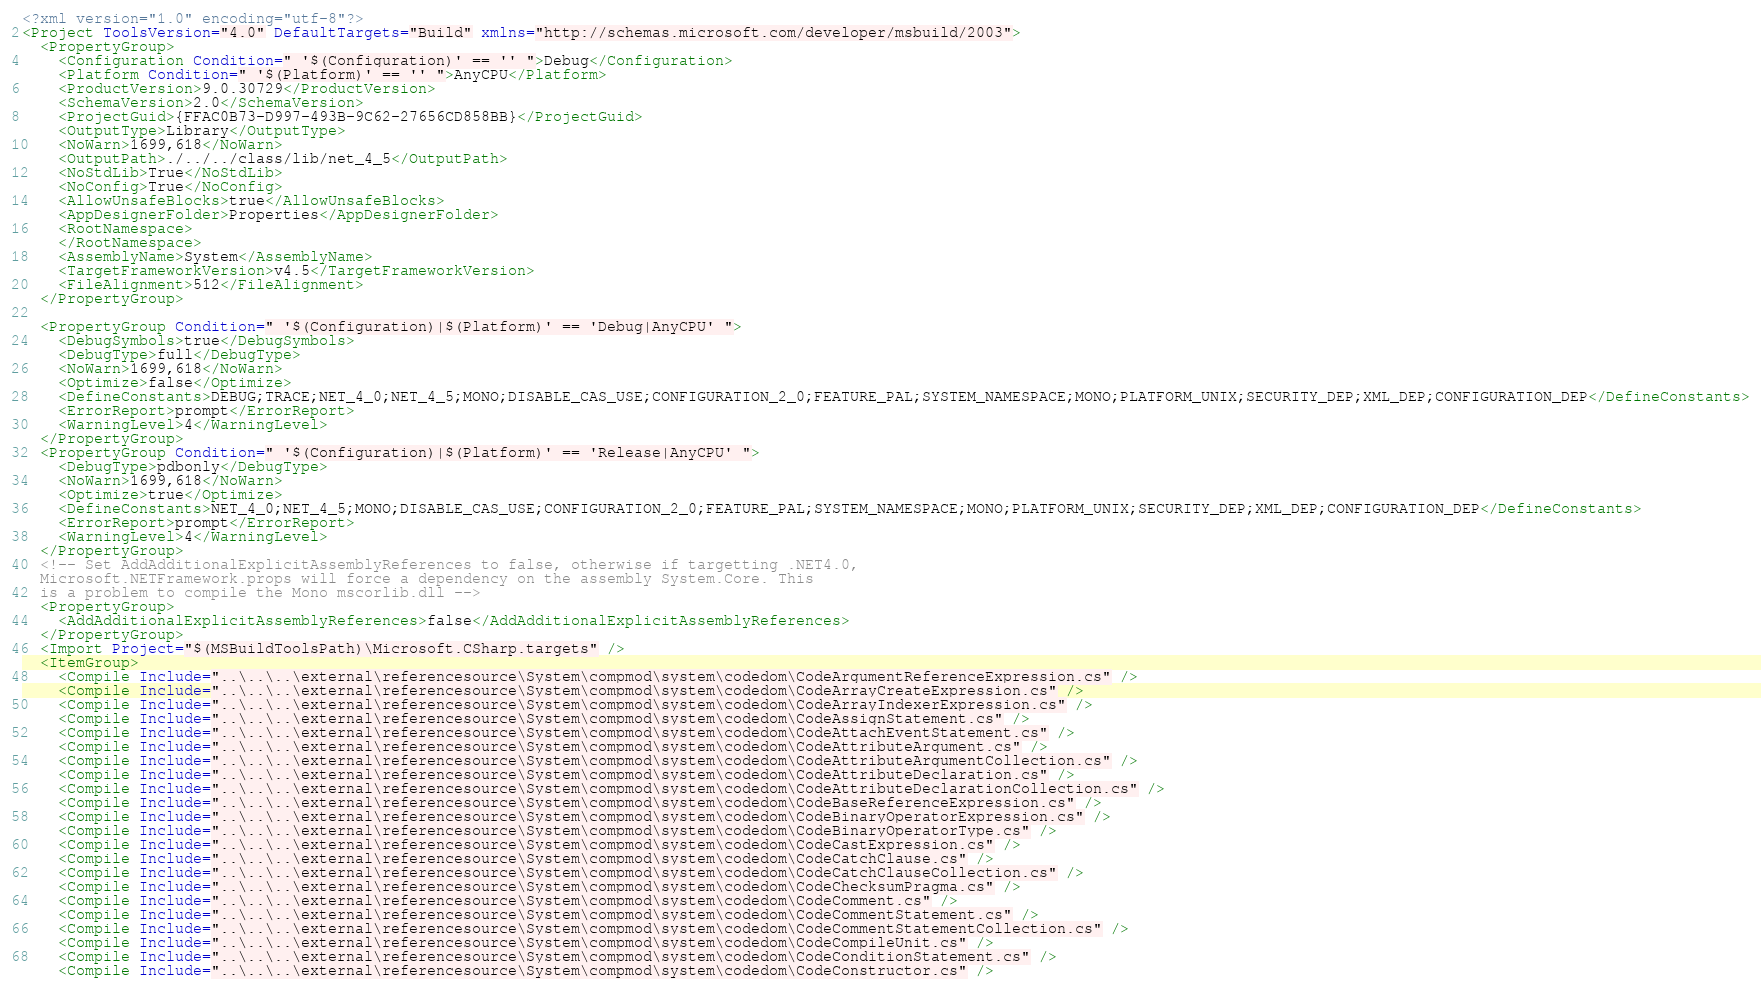<code> <loc_0><loc_0><loc_500><loc_500><_XML_><?xml version="1.0" encoding="utf-8"?>
<Project ToolsVersion="4.0" DefaultTargets="Build" xmlns="http://schemas.microsoft.com/developer/msbuild/2003">
  <PropertyGroup>
    <Configuration Condition=" '$(Configuration)' == '' ">Debug</Configuration>
    <Platform Condition=" '$(Platform)' == '' ">AnyCPU</Platform>
    <ProductVersion>9.0.30729</ProductVersion>
    <SchemaVersion>2.0</SchemaVersion>
    <ProjectGuid>{FFAC0B73-D997-493B-9C62-27656CD858BB}</ProjectGuid>
    <OutputType>Library</OutputType>
    <NoWarn>1699,618</NoWarn>
    <OutputPath>./../../class/lib/net_4_5</OutputPath>
    <NoStdLib>True</NoStdLib>
    <NoConfig>True</NoConfig>
    <AllowUnsafeBlocks>true</AllowUnsafeBlocks>
    <AppDesignerFolder>Properties</AppDesignerFolder>
    <RootNamespace>
    </RootNamespace>
    <AssemblyName>System</AssemblyName>
    <TargetFrameworkVersion>v4.5</TargetFrameworkVersion>
    <FileAlignment>512</FileAlignment>
  </PropertyGroup>
  
  <PropertyGroup Condition=" '$(Configuration)|$(Platform)' == 'Debug|AnyCPU' ">
    <DebugSymbols>true</DebugSymbols>
    <DebugType>full</DebugType>
    <NoWarn>1699,618</NoWarn>
    <Optimize>false</Optimize>
    <DefineConstants>DEBUG;TRACE;NET_4_0;NET_4_5;MONO;DISABLE_CAS_USE;CONFIGURATION_2_0;FEATURE_PAL;SYSTEM_NAMESPACE;MONO;PLATFORM_UNIX;SECURITY_DEP;XML_DEP;CONFIGURATION_DEP</DefineConstants>
    <ErrorReport>prompt</ErrorReport>
    <WarningLevel>4</WarningLevel>
  </PropertyGroup>
  <PropertyGroup Condition=" '$(Configuration)|$(Platform)' == 'Release|AnyCPU' ">
    <DebugType>pdbonly</DebugType>
    <NoWarn>1699,618</NoWarn>
    <Optimize>true</Optimize>
    <DefineConstants>NET_4_0;NET_4_5;MONO;DISABLE_CAS_USE;CONFIGURATION_2_0;FEATURE_PAL;SYSTEM_NAMESPACE;MONO;PLATFORM_UNIX;SECURITY_DEP;XML_DEP;CONFIGURATION_DEP</DefineConstants>
    <ErrorReport>prompt</ErrorReport>
    <WarningLevel>4</WarningLevel>
  </PropertyGroup>
  <!-- Set AddAdditionalExplicitAssemblyReferences to false, otherwise if targetting .NET4.0, 
  Microsoft.NETFramework.props will force a dependency on the assembly System.Core. This
  is a problem to compile the Mono mscorlib.dll -->
  <PropertyGroup>
    <AddAdditionalExplicitAssemblyReferences>false</AddAdditionalExplicitAssemblyReferences>
  </PropertyGroup>
  <Import Project="$(MSBuildToolsPath)\Microsoft.CSharp.targets" />
  <ItemGroup>
    <Compile Include="..\..\..\external\referencesource\System\compmod\system\codedom\CodeArgumentReferenceExpression.cs" />
    <Compile Include="..\..\..\external\referencesource\System\compmod\system\codedom\CodeArrayCreateExpression.cs" />
    <Compile Include="..\..\..\external\referencesource\System\compmod\system\codedom\CodeArrayIndexerExpression.cs" />
    <Compile Include="..\..\..\external\referencesource\System\compmod\system\codedom\CodeAssignStatement.cs" />
    <Compile Include="..\..\..\external\referencesource\System\compmod\system\codedom\CodeAttachEventStatement.cs" />
    <Compile Include="..\..\..\external\referencesource\System\compmod\system\codedom\CodeAttributeArgument.cs" />
    <Compile Include="..\..\..\external\referencesource\System\compmod\system\codedom\CodeAttributeArgumentCollection.cs" />
    <Compile Include="..\..\..\external\referencesource\System\compmod\system\codedom\CodeAttributeDeclaration.cs" />
    <Compile Include="..\..\..\external\referencesource\System\compmod\system\codedom\CodeAttributeDeclarationCollection.cs" />
    <Compile Include="..\..\..\external\referencesource\System\compmod\system\codedom\CodeBaseReferenceExpression.cs" />
    <Compile Include="..\..\..\external\referencesource\System\compmod\system\codedom\CodeBinaryOperatorExpression.cs" />
    <Compile Include="..\..\..\external\referencesource\System\compmod\system\codedom\CodeBinaryOperatorType.cs" />
    <Compile Include="..\..\..\external\referencesource\System\compmod\system\codedom\CodeCastExpression.cs" />
    <Compile Include="..\..\..\external\referencesource\System\compmod\system\codedom\CodeCatchClause.cs" />
    <Compile Include="..\..\..\external\referencesource\System\compmod\system\codedom\CodeCatchClauseCollection.cs" />
    <Compile Include="..\..\..\external\referencesource\System\compmod\system\codedom\CodeChecksumPragma.cs" />
    <Compile Include="..\..\..\external\referencesource\System\compmod\system\codedom\CodeComment.cs" />
    <Compile Include="..\..\..\external\referencesource\System\compmod\system\codedom\CodeCommentStatement.cs" />
    <Compile Include="..\..\..\external\referencesource\System\compmod\system\codedom\CodeCommentStatementCollection.cs" />
    <Compile Include="..\..\..\external\referencesource\System\compmod\system\codedom\CodeCompileUnit.cs" />
    <Compile Include="..\..\..\external\referencesource\System\compmod\system\codedom\CodeConditionStatement.cs" />
    <Compile Include="..\..\..\external\referencesource\System\compmod\system\codedom\CodeConstructor.cs" /></code> 